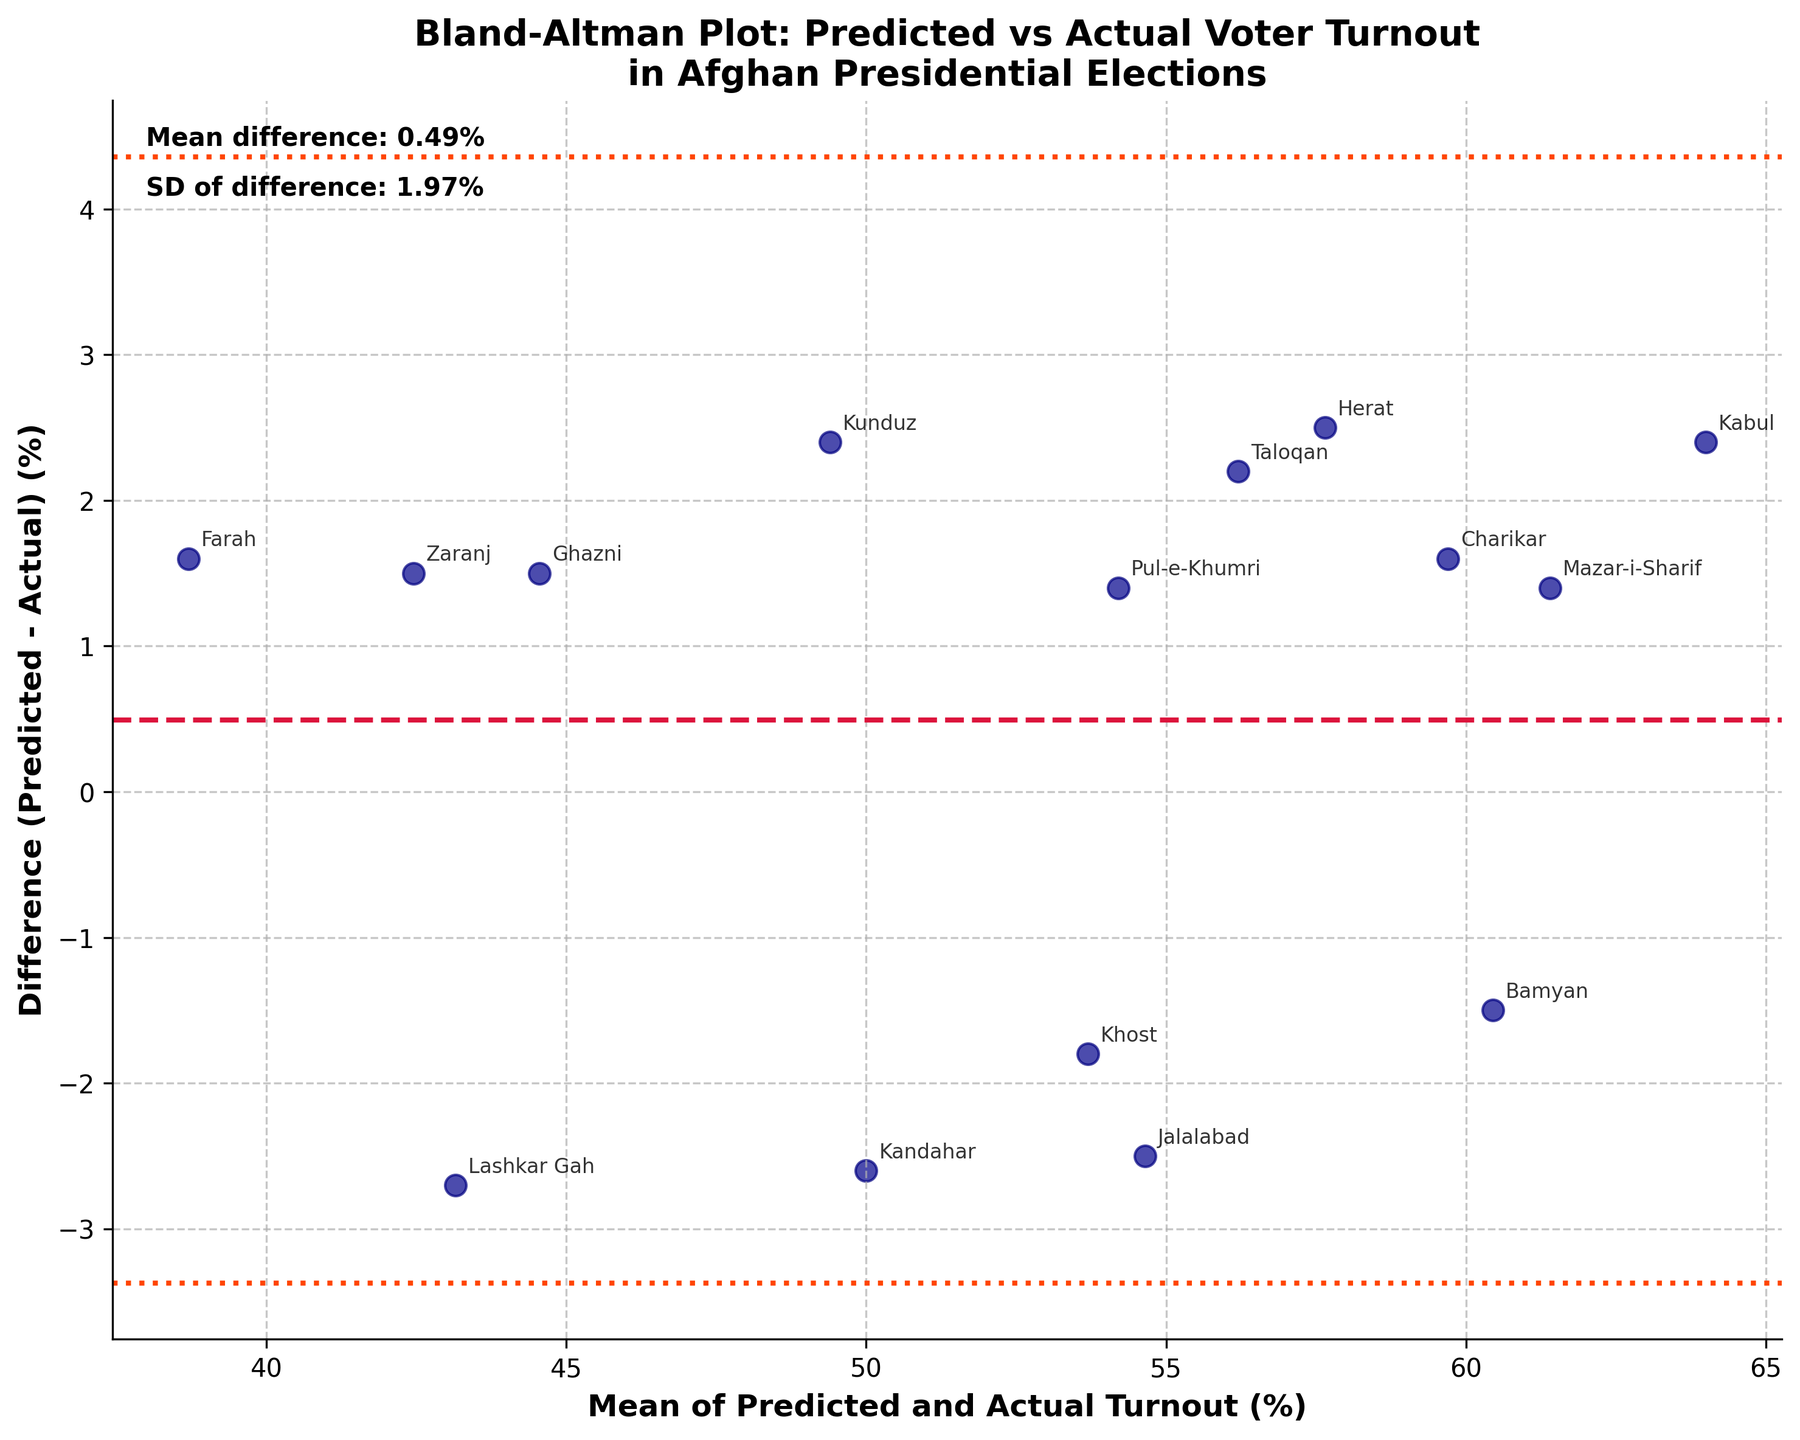How many data points are shown in the plot? The plot has a scatter element where each data point represents one region. There are 15 regions listed in the data provided.
Answer: 15 What is the title of the plot? The title is displayed at the top of the plot, summarizing what it represents.
Answer: Bland-Altman Plot: Predicted vs Actual Voter Turnout in Afghan Presidential Elections What do the horizontal dashed lines represent? These lines show the mean difference and the limits of agreement (mean difference ± 1.96 standard deviations). The middle dashed line represents the mean difference, and the dashed lines above and below it represent the upper and lower limits of agreement.
Answer: The mean difference and the limits of agreement Which region had the highest positive difference between predicted and actual turnout? Look for the data point with the highest value above the horizontal line (mean difference). Annotate it to see which region it represents.
Answer: Lashkar Gah Which regions have actual turnout rates higher than the predicted turnout rates? Identify the regions with difference values below 0, which means actual turnout rates are higher than predicted ones. Annotate these points to see the region names.
Answer: Kandahar, Jalalabad, Bamyan What's the mean of the predicted and actual turnout rates for Kabul? For Kabul, the mean can be calculated by averaging its predicted and actual turnout rates (65.2% and 62.8%). (65.2 + 62.8) / 2 = 64.0%
Answer: 64.0% What is the difference between predicted and actual turnout rates for Kunduz? The difference can be calculated by subtracting the actual turnout rate from the predicted value for Kunduz. 50.6 - 48.2 = 2.4%
Answer: 2.4% Which region lies closest to the mean difference line? Look for the region whose data point lies nearest to the horizontal dashed line representing the mean difference. Annotate this point to see the region's name.
Answer: Pul-e-Khumri What is the standard deviation of the difference in turnout rates? This value is noted in the text annotations within the plot itself. It will likely be labelled as "SD of difference".
Answer: 2.29% Which regions fall outside the limits of agreement? Identify the data points that fall outside the upper and lower dashed lines representing the limits of agreement. Annotate these points to reveal the region names.
Answer: Lashkar Gah 